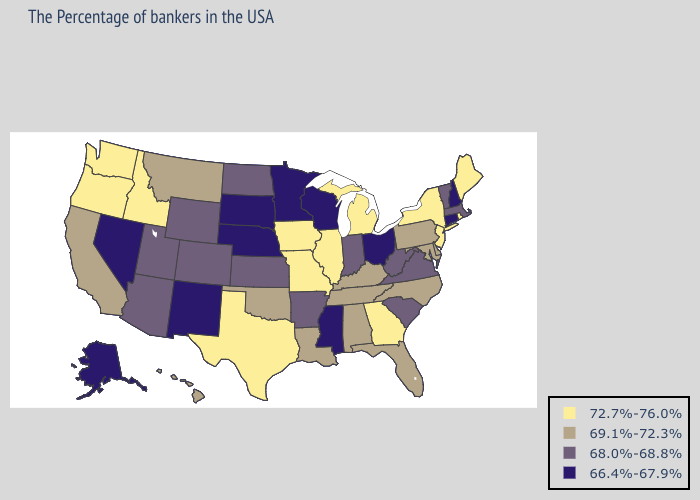Name the states that have a value in the range 72.7%-76.0%?
Be succinct. Maine, Rhode Island, New York, New Jersey, Georgia, Michigan, Illinois, Missouri, Iowa, Texas, Idaho, Washington, Oregon. Does Virginia have the highest value in the South?
Answer briefly. No. What is the value of New Mexico?
Keep it brief. 66.4%-67.9%. What is the highest value in states that border Alabama?
Give a very brief answer. 72.7%-76.0%. Does Texas have the highest value in the South?
Short answer required. Yes. Which states have the lowest value in the West?
Be succinct. New Mexico, Nevada, Alaska. Name the states that have a value in the range 72.7%-76.0%?
Keep it brief. Maine, Rhode Island, New York, New Jersey, Georgia, Michigan, Illinois, Missouri, Iowa, Texas, Idaho, Washington, Oregon. Name the states that have a value in the range 66.4%-67.9%?
Keep it brief. New Hampshire, Connecticut, Ohio, Wisconsin, Mississippi, Minnesota, Nebraska, South Dakota, New Mexico, Nevada, Alaska. Does Kentucky have the lowest value in the South?
Answer briefly. No. What is the highest value in states that border Nevada?
Be succinct. 72.7%-76.0%. Among the states that border Alabama , which have the highest value?
Give a very brief answer. Georgia. What is the value of New York?
Concise answer only. 72.7%-76.0%. Does South Carolina have a lower value than Idaho?
Concise answer only. Yes. Does Vermont have the lowest value in the USA?
Quick response, please. No. Name the states that have a value in the range 66.4%-67.9%?
Answer briefly. New Hampshire, Connecticut, Ohio, Wisconsin, Mississippi, Minnesota, Nebraska, South Dakota, New Mexico, Nevada, Alaska. 